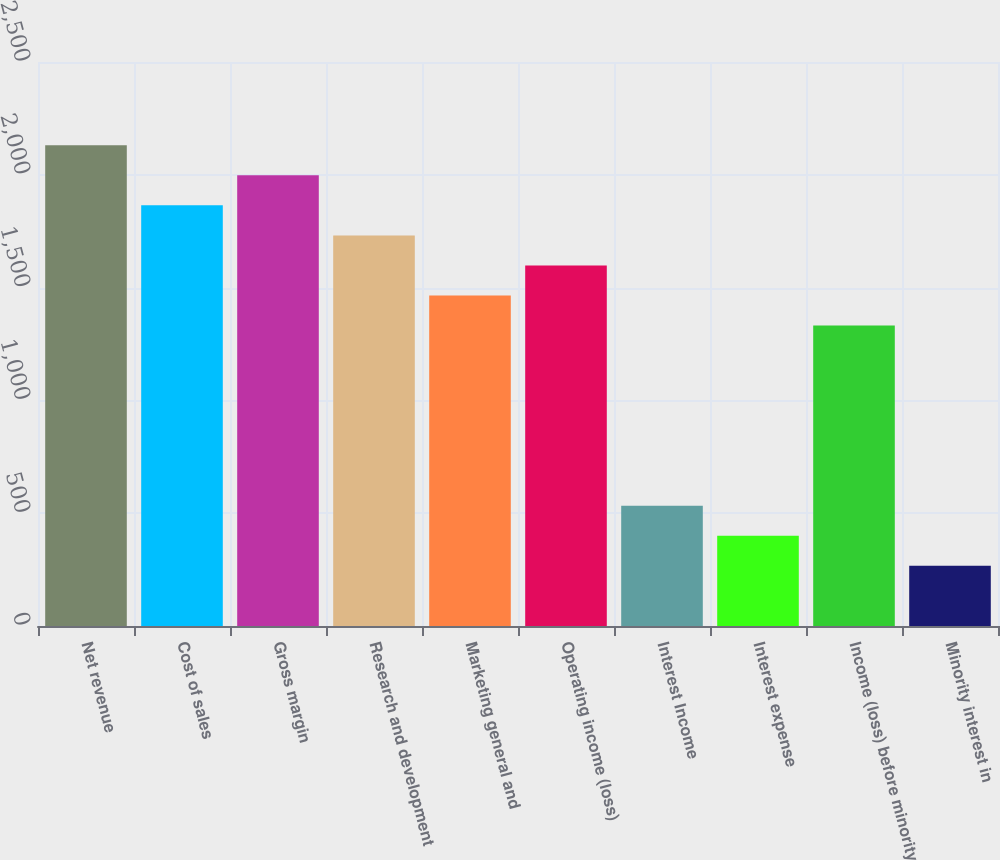Convert chart to OTSL. <chart><loc_0><loc_0><loc_500><loc_500><bar_chart><fcel>Net revenue<fcel>Cost of sales<fcel>Gross margin<fcel>Research and development<fcel>Marketing general and<fcel>Operating income (loss)<fcel>Interest Income<fcel>Interest expense<fcel>Income (loss) before minority<fcel>Minority interest in<nl><fcel>2130.94<fcel>1864.62<fcel>1997.78<fcel>1731.46<fcel>1465.14<fcel>1598.3<fcel>533.02<fcel>399.86<fcel>1331.98<fcel>266.7<nl></chart> 